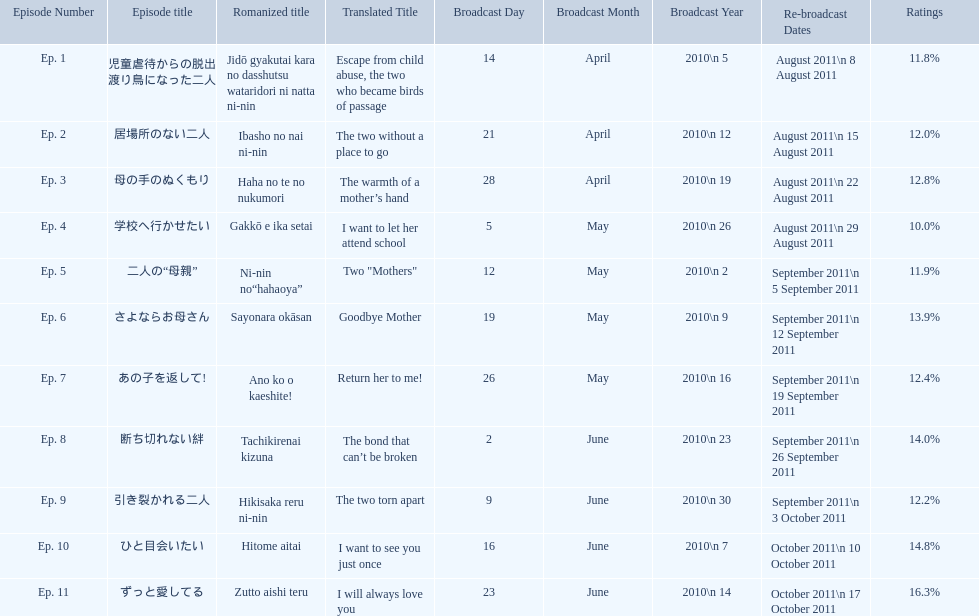Other than the 10th episode, which other episode has a 14% rating? Ep. 8. 